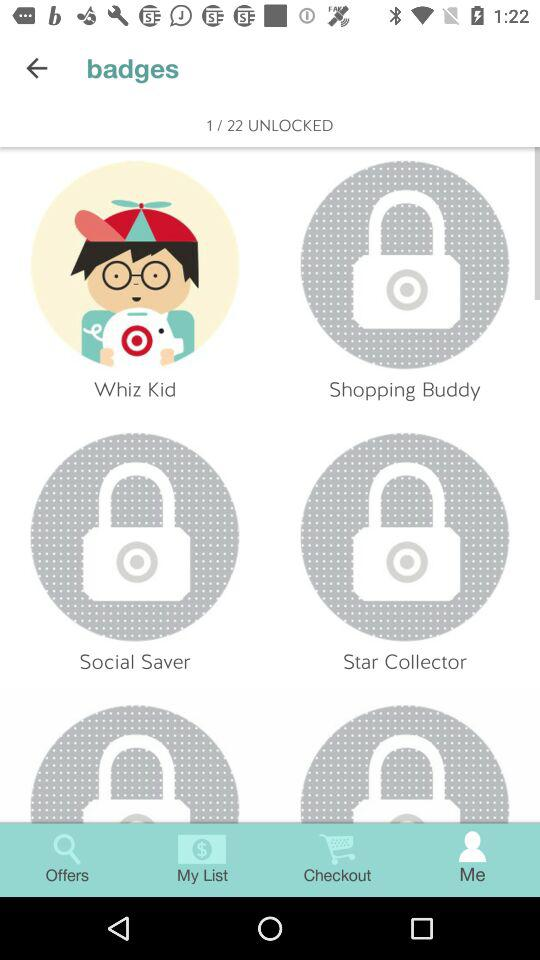How many unlocked badges are there? There is 1 unlocked badge. 